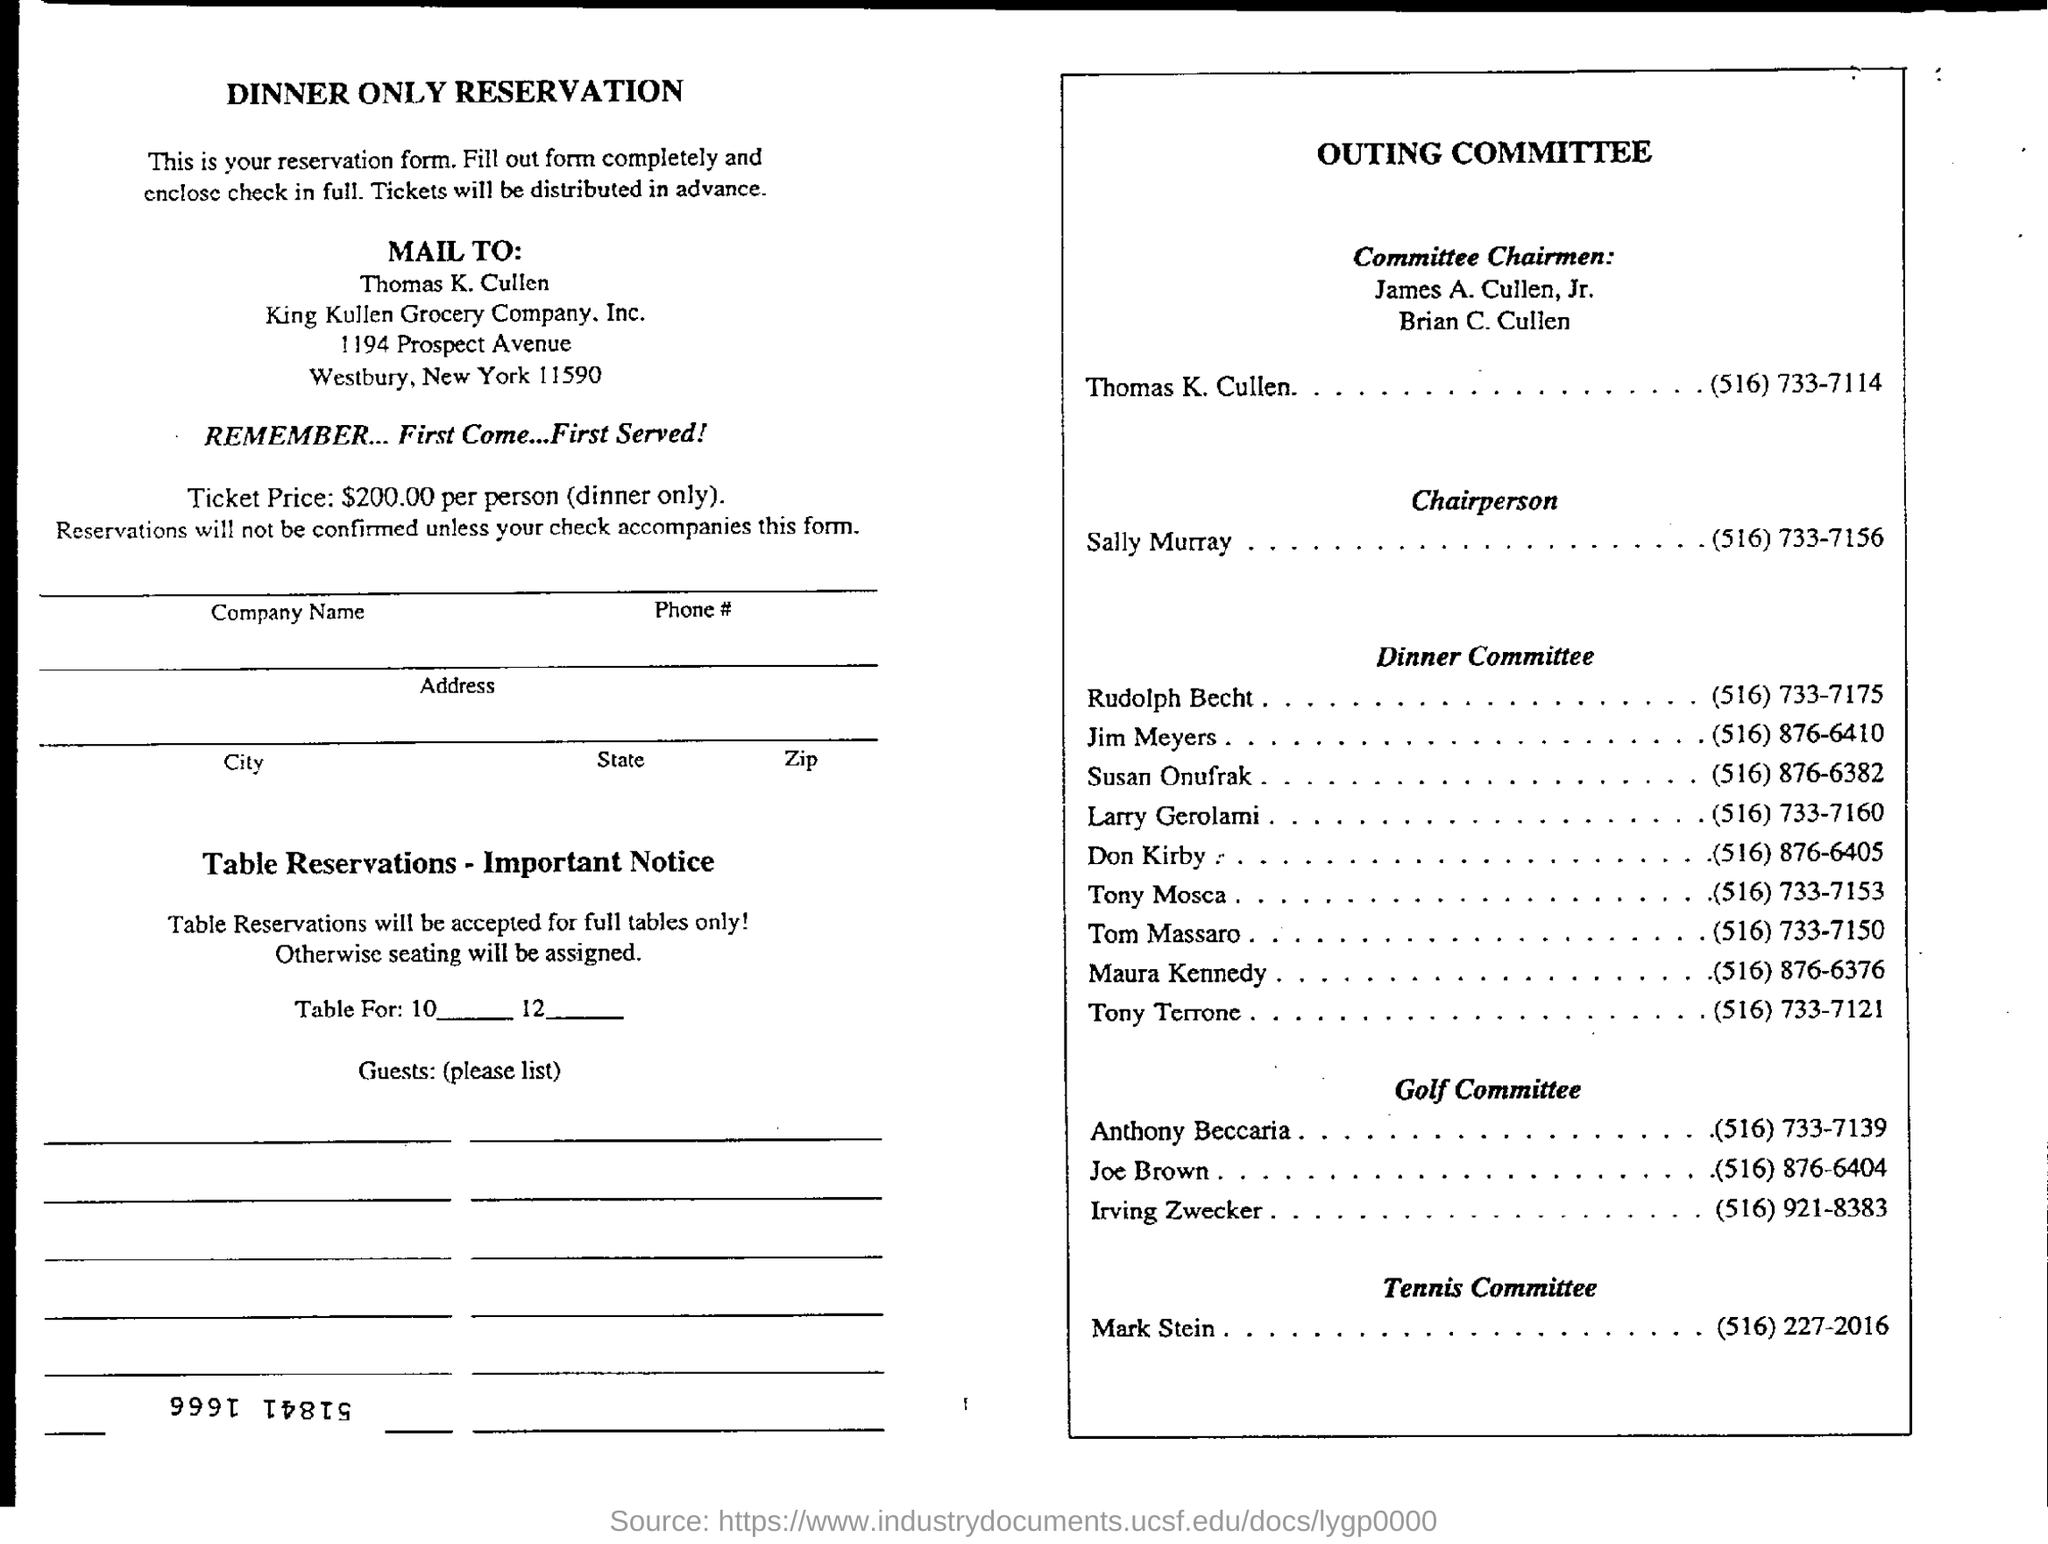Indicate a few pertinent items in this graphic. The telephone number of Sally Murray is (516) 733-7156. King Kullen Grocery Company, Inc. is located in the state of New York. Mark Stein's telephone number is (516) 227-2016, The price of the ticket for dinner is $200 per person. 